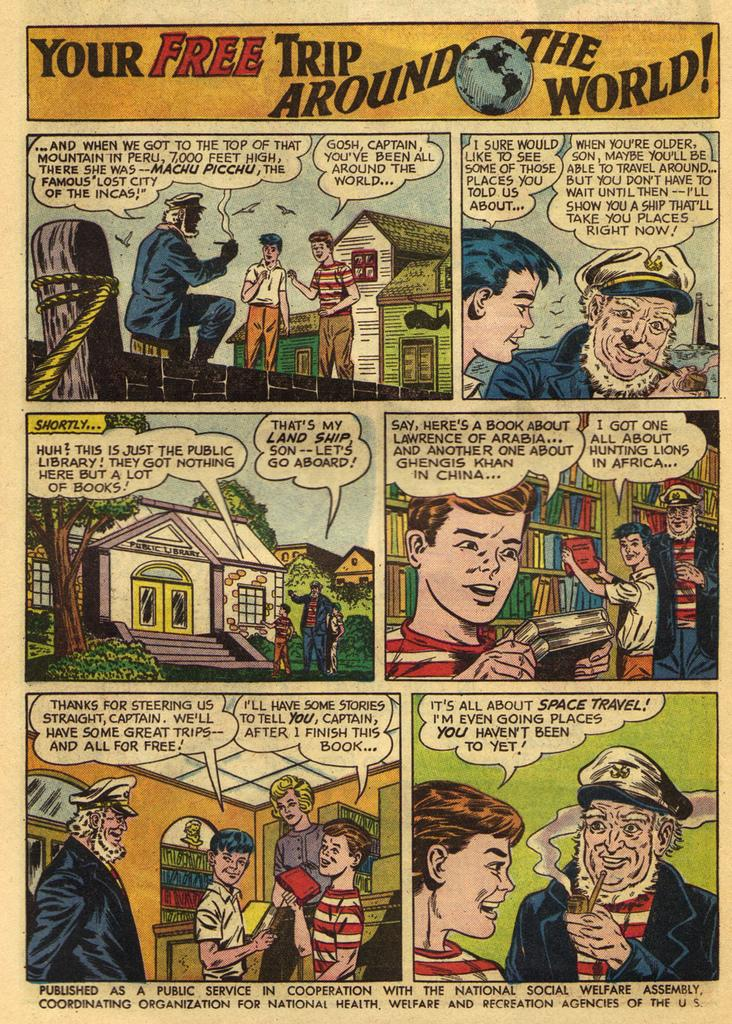<image>
Describe the image concisely. A comic book story is tantalizingly titled Your Free Trip Around the World. 